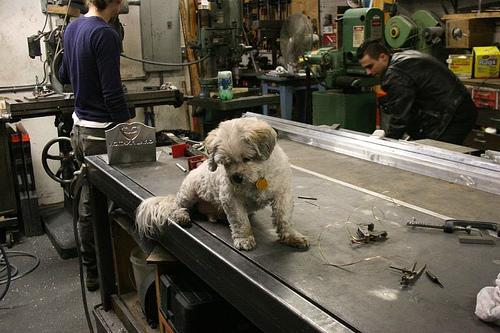What work is done in this space?

Choices:
A) coding
B) machine shop
C) cooking
D) typing machine shop 